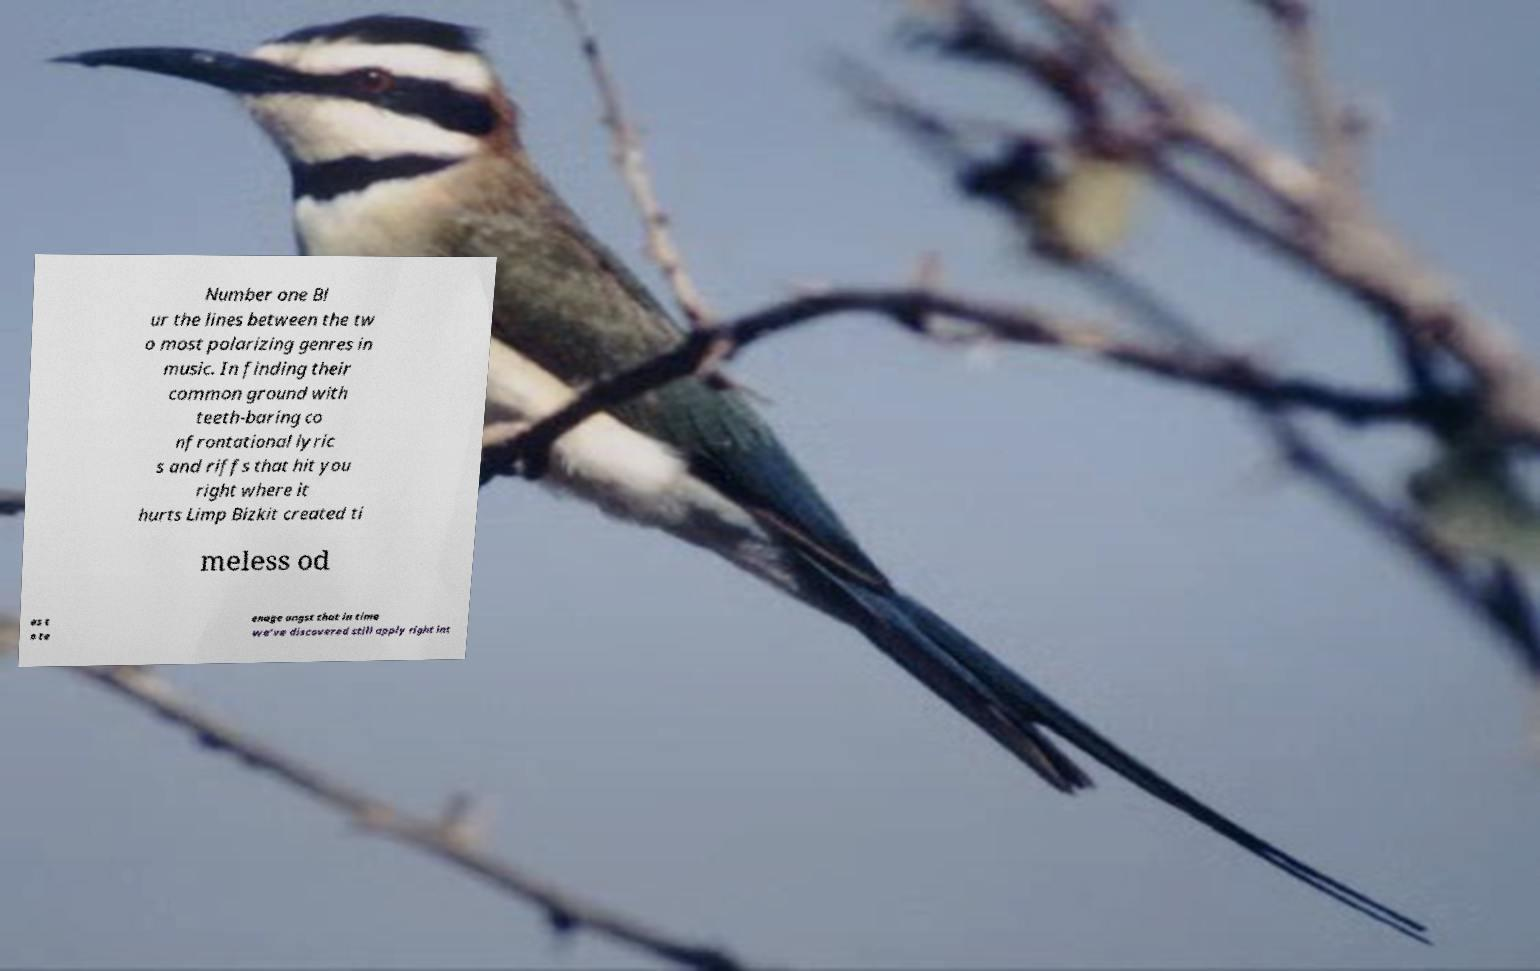For documentation purposes, I need the text within this image transcribed. Could you provide that? Number one Bl ur the lines between the tw o most polarizing genres in music. In finding their common ground with teeth-baring co nfrontational lyric s and riffs that hit you right where it hurts Limp Bizkit created ti meless od es t o te enage angst that in time we’ve discovered still apply right int 